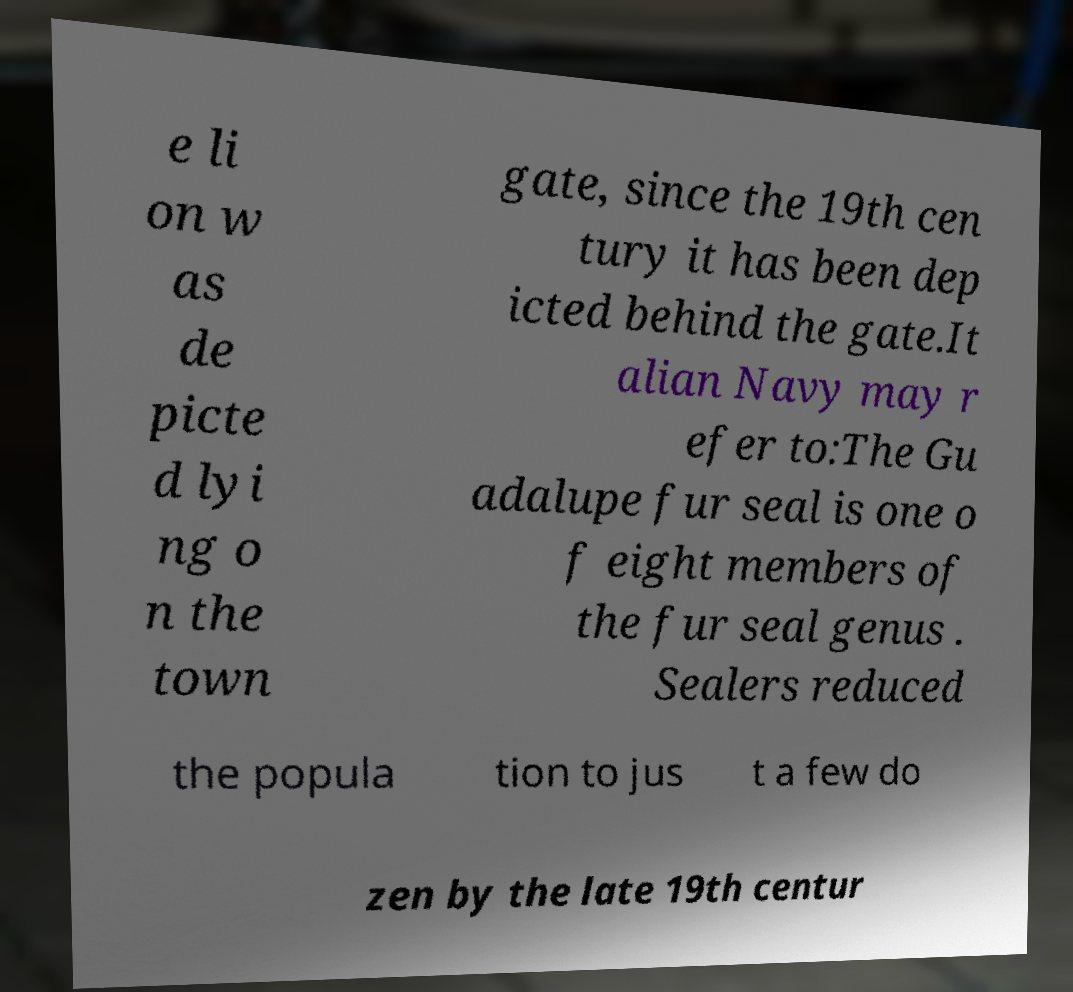For documentation purposes, I need the text within this image transcribed. Could you provide that? e li on w as de picte d lyi ng o n the town gate, since the 19th cen tury it has been dep icted behind the gate.It alian Navy may r efer to:The Gu adalupe fur seal is one o f eight members of the fur seal genus . Sealers reduced the popula tion to jus t a few do zen by the late 19th centur 